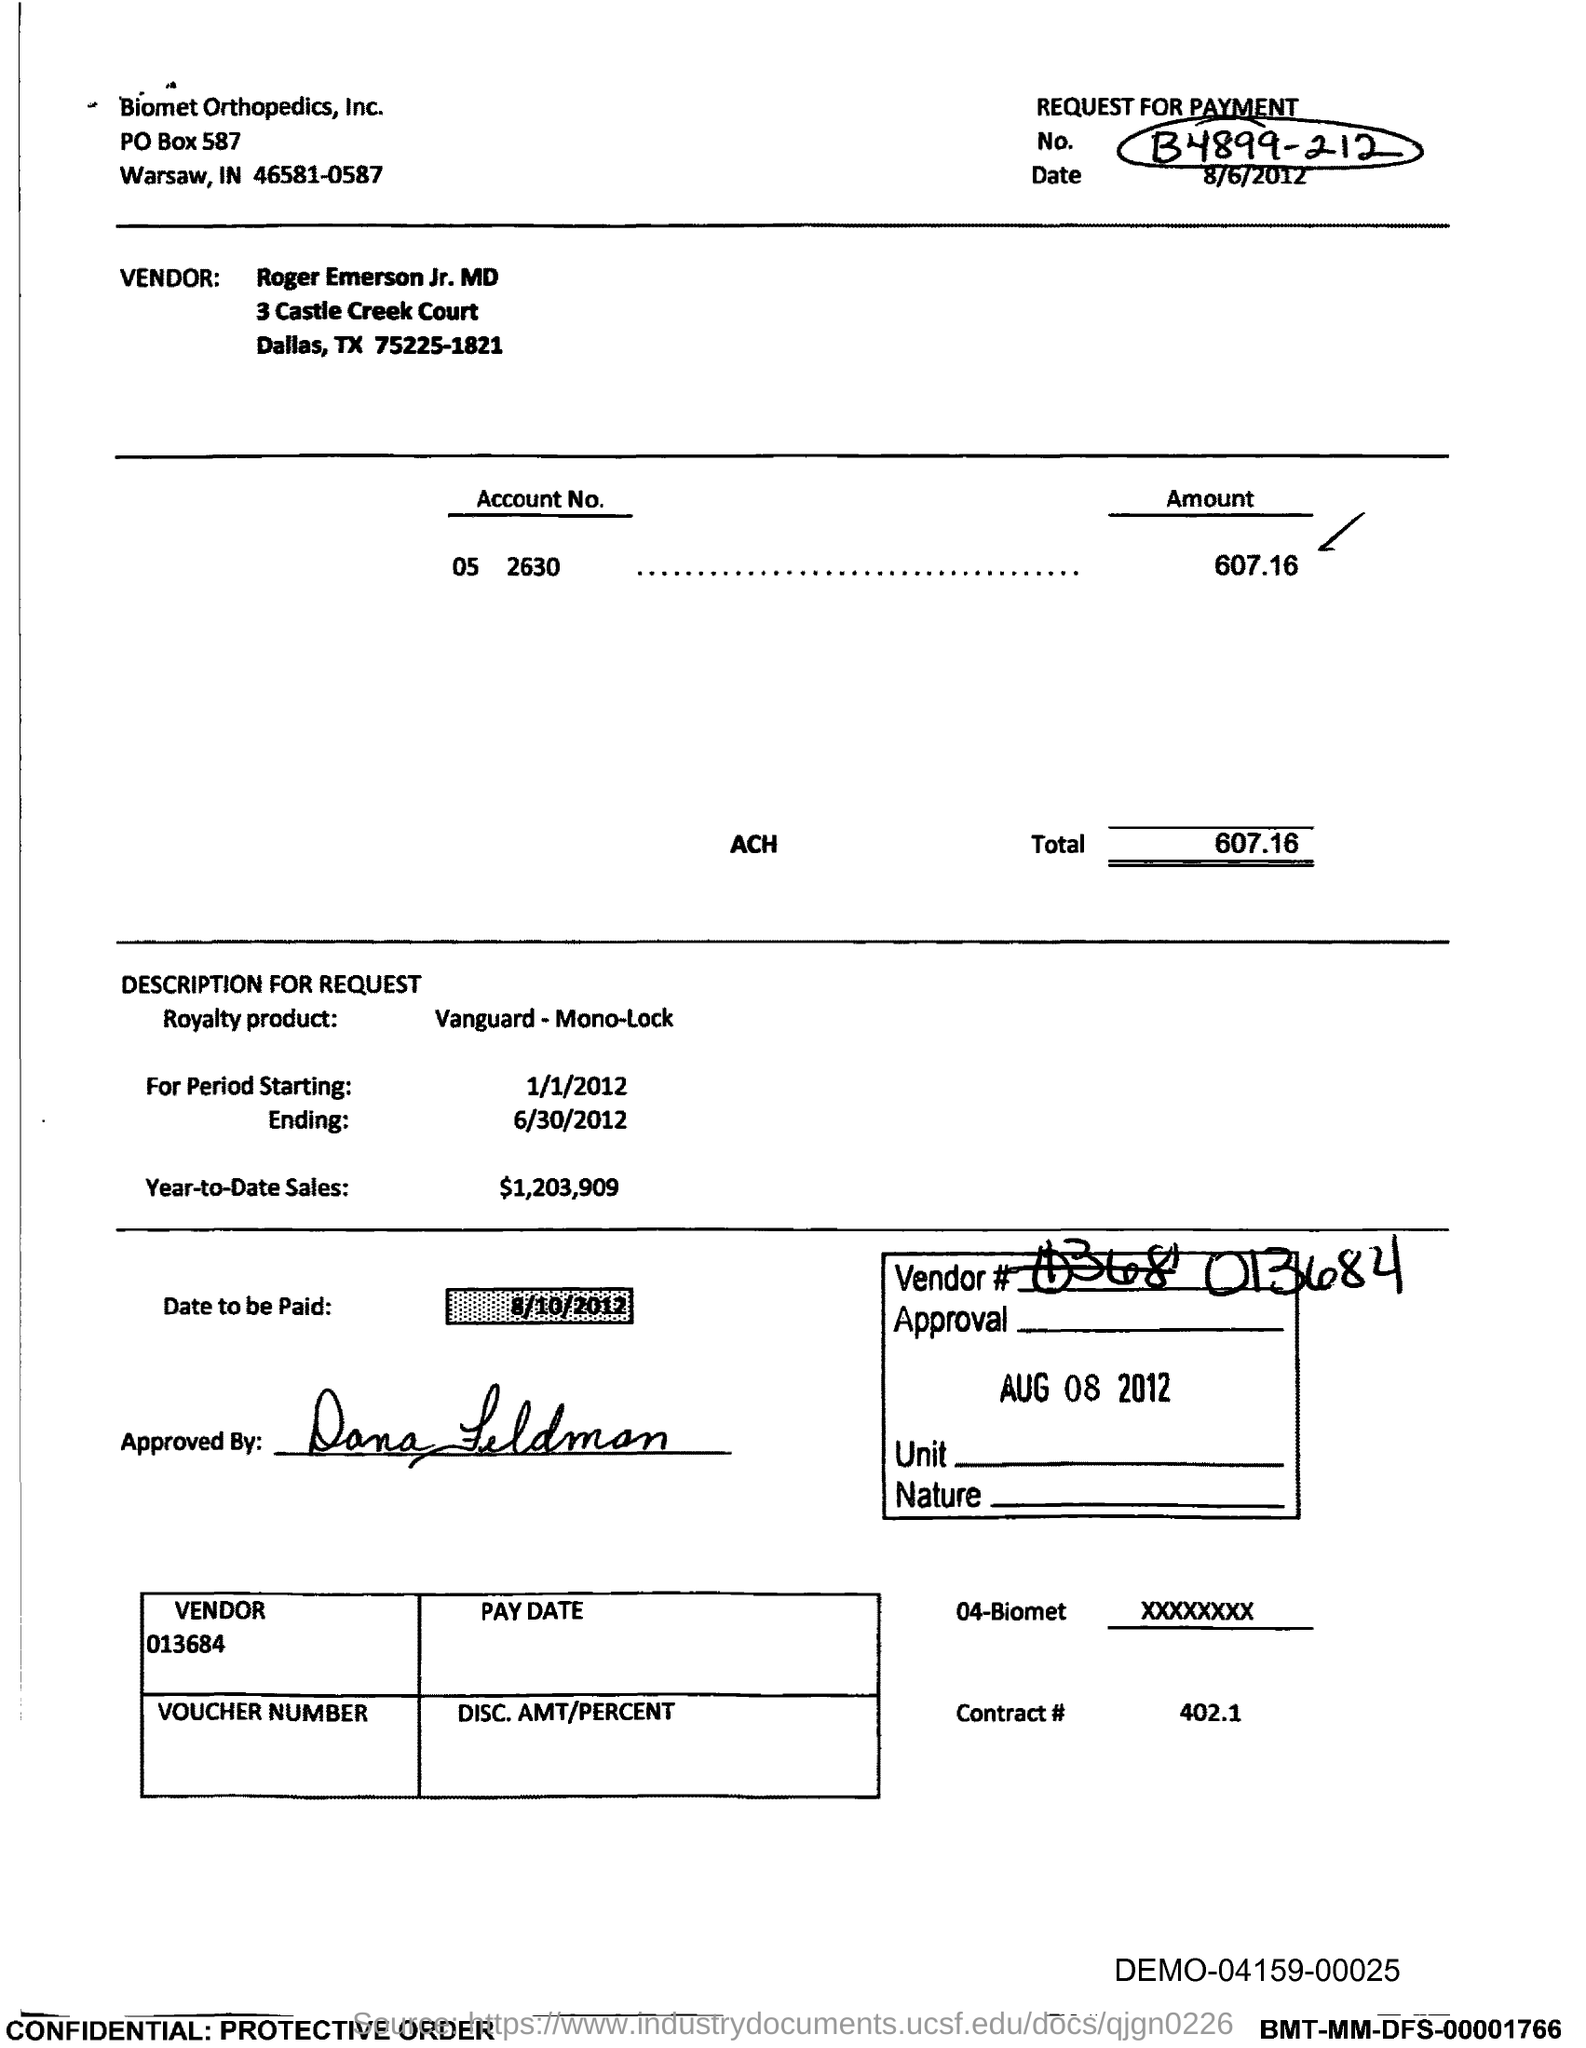List a handful of essential elements in this visual. The date upon which the payment is to be made, as specified in the document, is 8/10/2012. The year-to-date sales mentioned in the document are 1,203,909. The date mentioned in the box is August 8th, 2012. What is the total amount of 607.16...? 